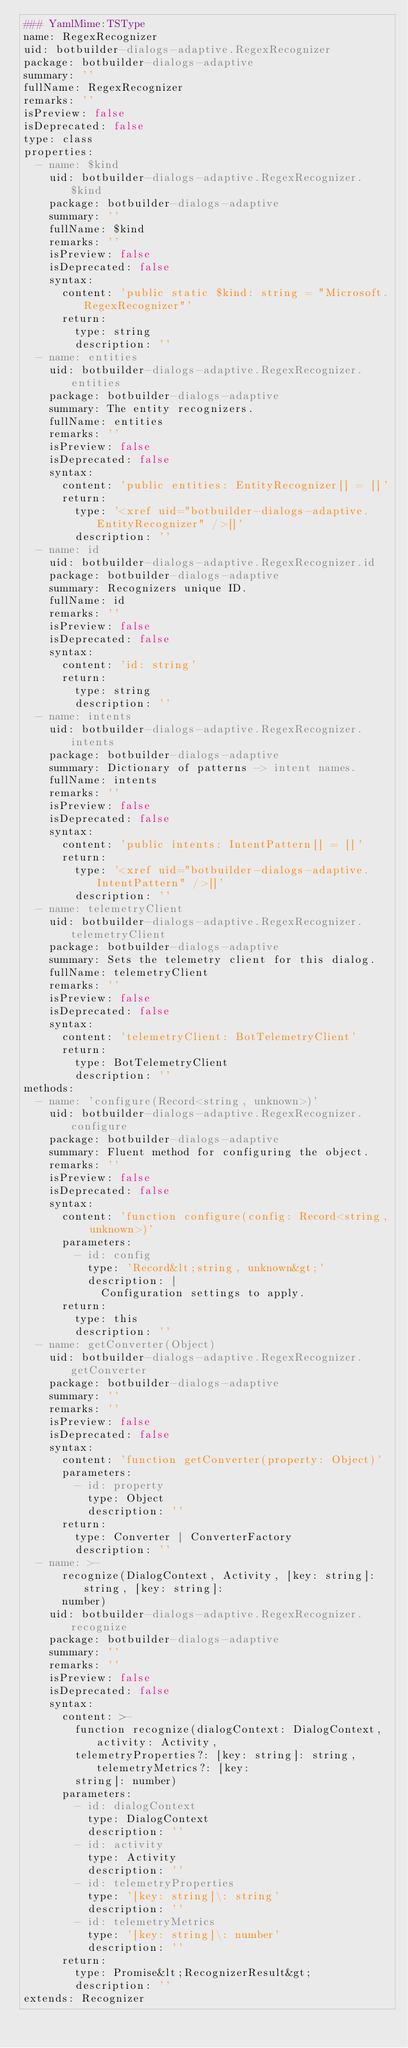Convert code to text. <code><loc_0><loc_0><loc_500><loc_500><_YAML_>### YamlMime:TSType
name: RegexRecognizer
uid: botbuilder-dialogs-adaptive.RegexRecognizer
package: botbuilder-dialogs-adaptive
summary: ''
fullName: RegexRecognizer
remarks: ''
isPreview: false
isDeprecated: false
type: class
properties:
  - name: $kind
    uid: botbuilder-dialogs-adaptive.RegexRecognizer.$kind
    package: botbuilder-dialogs-adaptive
    summary: ''
    fullName: $kind
    remarks: ''
    isPreview: false
    isDeprecated: false
    syntax:
      content: 'public static $kind: string = "Microsoft.RegexRecognizer"'
      return:
        type: string
        description: ''
  - name: entities
    uid: botbuilder-dialogs-adaptive.RegexRecognizer.entities
    package: botbuilder-dialogs-adaptive
    summary: The entity recognizers.
    fullName: entities
    remarks: ''
    isPreview: false
    isDeprecated: false
    syntax:
      content: 'public entities: EntityRecognizer[] = []'
      return:
        type: '<xref uid="botbuilder-dialogs-adaptive.EntityRecognizer" />[]'
        description: ''
  - name: id
    uid: botbuilder-dialogs-adaptive.RegexRecognizer.id
    package: botbuilder-dialogs-adaptive
    summary: Recognizers unique ID.
    fullName: id
    remarks: ''
    isPreview: false
    isDeprecated: false
    syntax:
      content: 'id: string'
      return:
        type: string
        description: ''
  - name: intents
    uid: botbuilder-dialogs-adaptive.RegexRecognizer.intents
    package: botbuilder-dialogs-adaptive
    summary: Dictionary of patterns -> intent names.
    fullName: intents
    remarks: ''
    isPreview: false
    isDeprecated: false
    syntax:
      content: 'public intents: IntentPattern[] = []'
      return:
        type: '<xref uid="botbuilder-dialogs-adaptive.IntentPattern" />[]'
        description: ''
  - name: telemetryClient
    uid: botbuilder-dialogs-adaptive.RegexRecognizer.telemetryClient
    package: botbuilder-dialogs-adaptive
    summary: Sets the telemetry client for this dialog.
    fullName: telemetryClient
    remarks: ''
    isPreview: false
    isDeprecated: false
    syntax:
      content: 'telemetryClient: BotTelemetryClient'
      return:
        type: BotTelemetryClient
        description: ''
methods:
  - name: 'configure(Record<string, unknown>)'
    uid: botbuilder-dialogs-adaptive.RegexRecognizer.configure
    package: botbuilder-dialogs-adaptive
    summary: Fluent method for configuring the object.
    remarks: ''
    isPreview: false
    isDeprecated: false
    syntax:
      content: 'function configure(config: Record<string, unknown>)'
      parameters:
        - id: config
          type: 'Record&lt;string, unknown&gt;'
          description: |
            Configuration settings to apply.
      return:
        type: this
        description: ''
  - name: getConverter(Object)
    uid: botbuilder-dialogs-adaptive.RegexRecognizer.getConverter
    package: botbuilder-dialogs-adaptive
    summary: ''
    remarks: ''
    isPreview: false
    isDeprecated: false
    syntax:
      content: 'function getConverter(property: Object)'
      parameters:
        - id: property
          type: Object
          description: ''
      return:
        type: Converter | ConverterFactory
        description: ''
  - name: >-
      recognize(DialogContext, Activity, [key: string]: string, [key: string]:
      number)
    uid: botbuilder-dialogs-adaptive.RegexRecognizer.recognize
    package: botbuilder-dialogs-adaptive
    summary: ''
    remarks: ''
    isPreview: false
    isDeprecated: false
    syntax:
      content: >-
        function recognize(dialogContext: DialogContext, activity: Activity,
        telemetryProperties?: [key: string]: string, telemetryMetrics?: [key:
        string]: number)
      parameters:
        - id: dialogContext
          type: DialogContext
          description: ''
        - id: activity
          type: Activity
          description: ''
        - id: telemetryProperties
          type: '[key: string]\: string'
          description: ''
        - id: telemetryMetrics
          type: '[key: string]\: number'
          description: ''
      return:
        type: Promise&lt;RecognizerResult&gt;
        description: ''
extends: Recognizer
</code> 